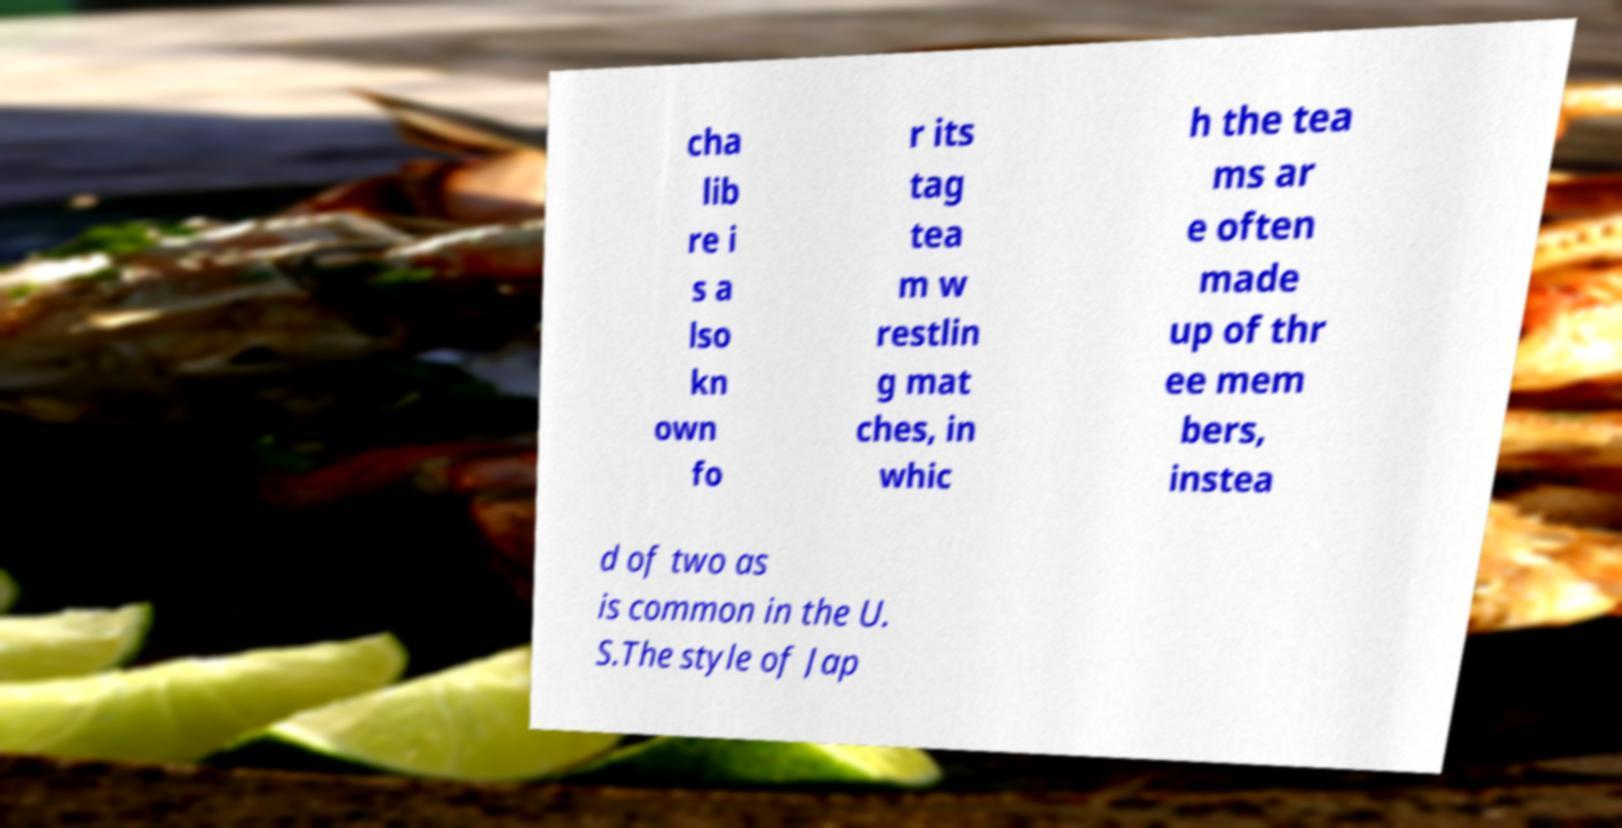There's text embedded in this image that I need extracted. Can you transcribe it verbatim? cha lib re i s a lso kn own fo r its tag tea m w restlin g mat ches, in whic h the tea ms ar e often made up of thr ee mem bers, instea d of two as is common in the U. S.The style of Jap 